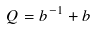Convert formula to latex. <formula><loc_0><loc_0><loc_500><loc_500>Q = b ^ { - 1 } + b</formula> 